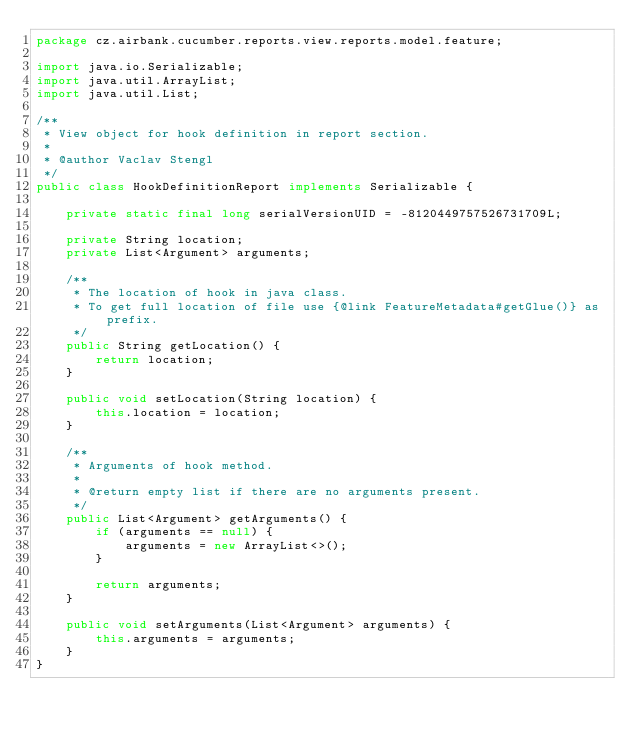<code> <loc_0><loc_0><loc_500><loc_500><_Java_>package cz.airbank.cucumber.reports.view.reports.model.feature;

import java.io.Serializable;
import java.util.ArrayList;
import java.util.List;

/**
 * View object for hook definition in report section.
 *
 * @author Vaclav Stengl
 */
public class HookDefinitionReport implements Serializable {

    private static final long serialVersionUID = -8120449757526731709L;

    private String location;
    private List<Argument> arguments;

    /**
     * The location of hook in java class.
     * To get full location of file use {@link FeatureMetadata#getGlue()} as prefix.
     */
    public String getLocation() {
        return location;
    }

    public void setLocation(String location) {
        this.location = location;
    }

    /**
     * Arguments of hook method.
     *
     * @return empty list if there are no arguments present.
     */
    public List<Argument> getArguments() {
        if (arguments == null) {
            arguments = new ArrayList<>();
        }

        return arguments;
    }

    public void setArguments(List<Argument> arguments) {
        this.arguments = arguments;
    }
}
</code> 